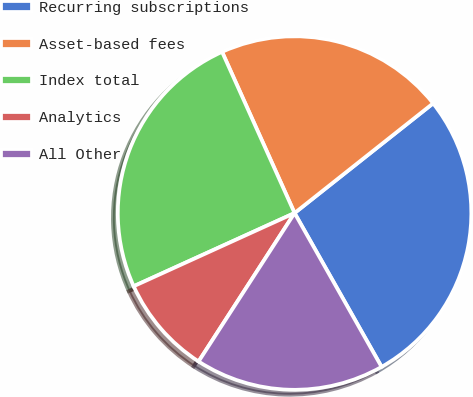Convert chart to OTSL. <chart><loc_0><loc_0><loc_500><loc_500><pie_chart><fcel>Recurring subscriptions<fcel>Asset-based fees<fcel>Index total<fcel>Analytics<fcel>All Other<nl><fcel>27.47%<fcel>21.07%<fcel>25.07%<fcel>9.07%<fcel>17.33%<nl></chart> 